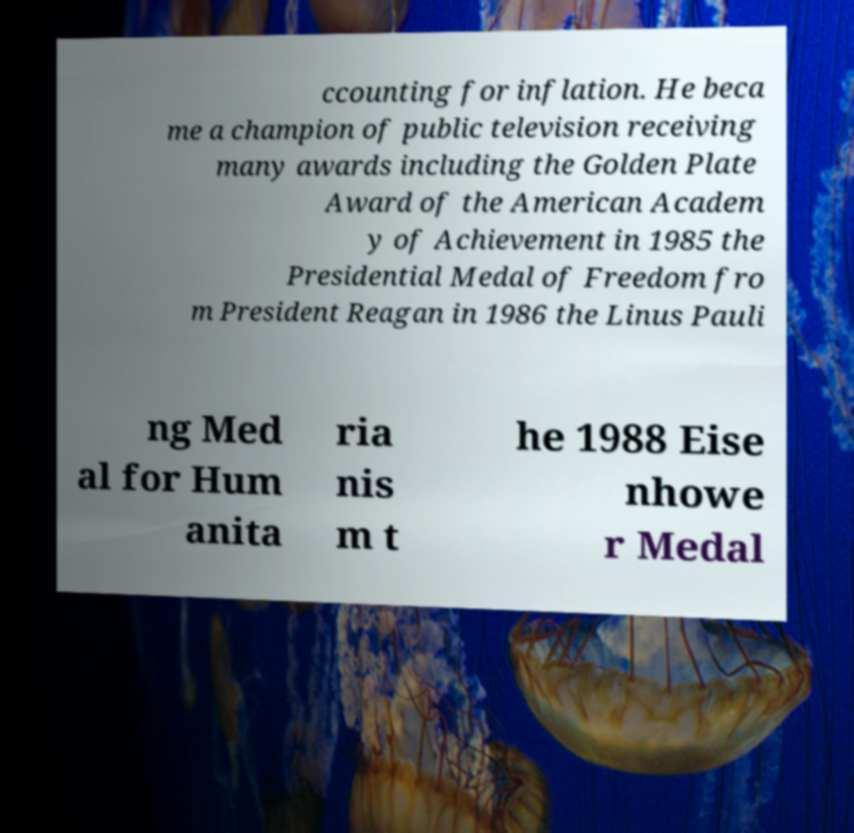Can you accurately transcribe the text from the provided image for me? ccounting for inflation. He beca me a champion of public television receiving many awards including the Golden Plate Award of the American Academ y of Achievement in 1985 the Presidential Medal of Freedom fro m President Reagan in 1986 the Linus Pauli ng Med al for Hum anita ria nis m t he 1988 Eise nhowe r Medal 